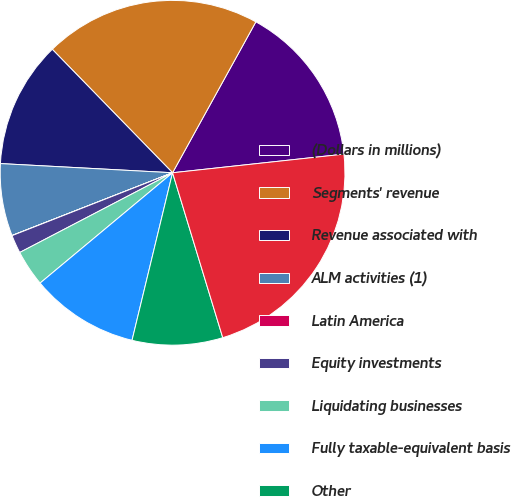<chart> <loc_0><loc_0><loc_500><loc_500><pie_chart><fcel>(Dollars in millions)<fcel>Segments' revenue<fcel>Revenue associated with<fcel>ALM activities (1)<fcel>Latin America<fcel>Equity investments<fcel>Liquidating businesses<fcel>Fully taxable-equivalent basis<fcel>Other<fcel>Consolidated revenue<nl><fcel>15.25%<fcel>20.32%<fcel>11.86%<fcel>6.78%<fcel>0.01%<fcel>1.71%<fcel>3.4%<fcel>10.17%<fcel>8.48%<fcel>22.02%<nl></chart> 